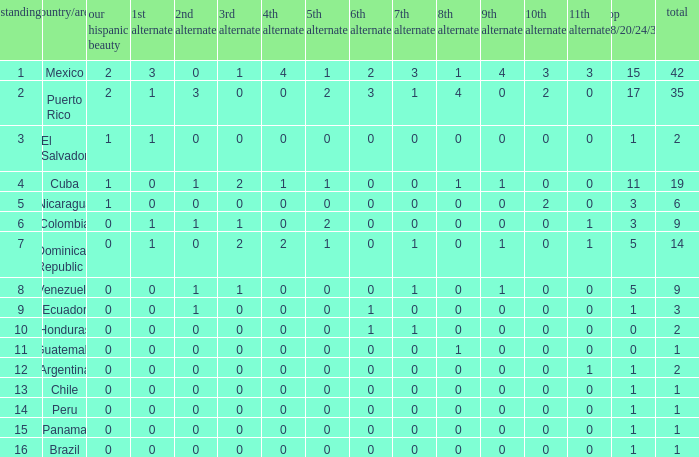What is the 3rd runner-up of the country with more than 0 9th runner-up, an 11th runner-up of 0, and the 1st runner-up greater than 0? None. 